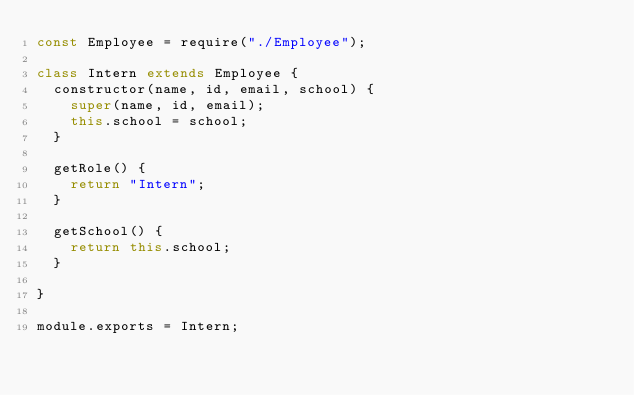<code> <loc_0><loc_0><loc_500><loc_500><_JavaScript_>const Employee = require("./Employee");

class Intern extends Employee {
  constructor(name, id, email, school) {
    super(name, id, email);
    this.school = school;
  }

  getRole() {
    return "Intern";
  }

  getSchool() {
    return this.school;
  }
    
}

module.exports = Intern;
</code> 